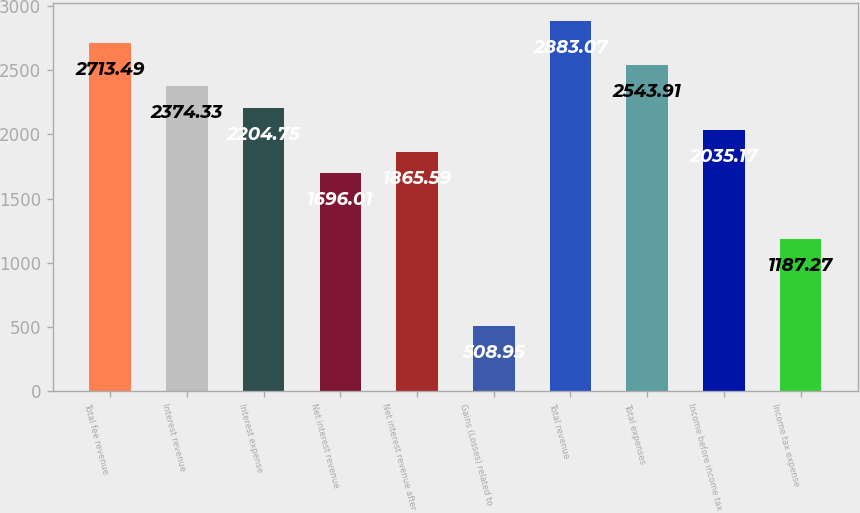Convert chart. <chart><loc_0><loc_0><loc_500><loc_500><bar_chart><fcel>Total fee revenue<fcel>Interest revenue<fcel>Interest expense<fcel>Net interest revenue<fcel>Net interest revenue after<fcel>Gains (Losses) related to<fcel>Total revenue<fcel>Total expenses<fcel>Income before income tax<fcel>Income tax expense<nl><fcel>2713.49<fcel>2374.33<fcel>2204.75<fcel>1696.01<fcel>1865.59<fcel>508.95<fcel>2883.07<fcel>2543.91<fcel>2035.17<fcel>1187.27<nl></chart> 